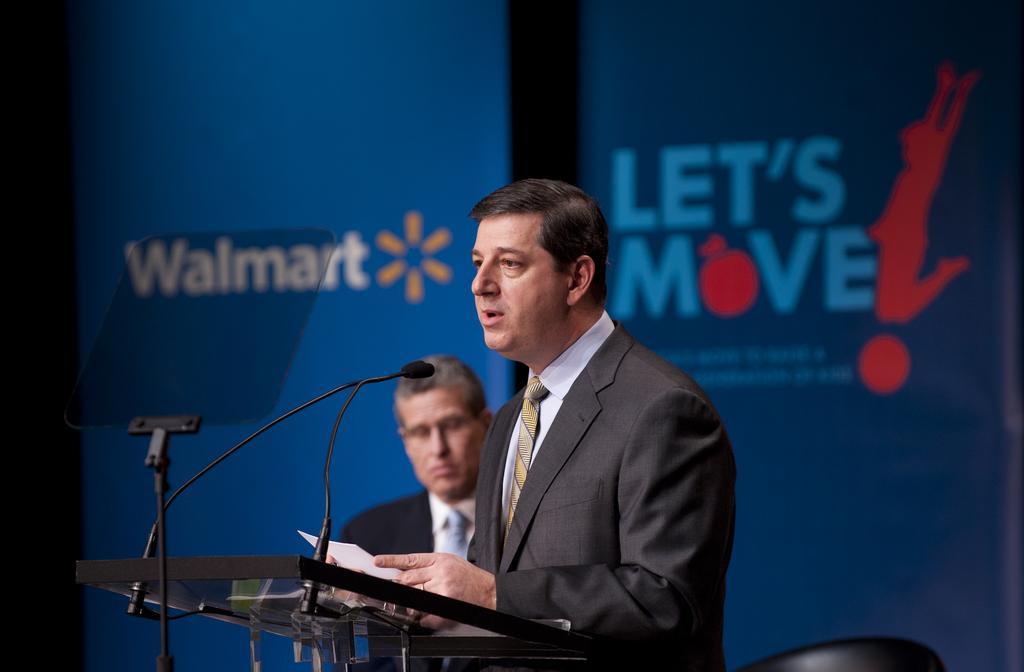Can you describe this image briefly? In this image we can see persons standing and one of them is standing at the lectern by holding a paper in the hands. In the background we can see advertisements. 